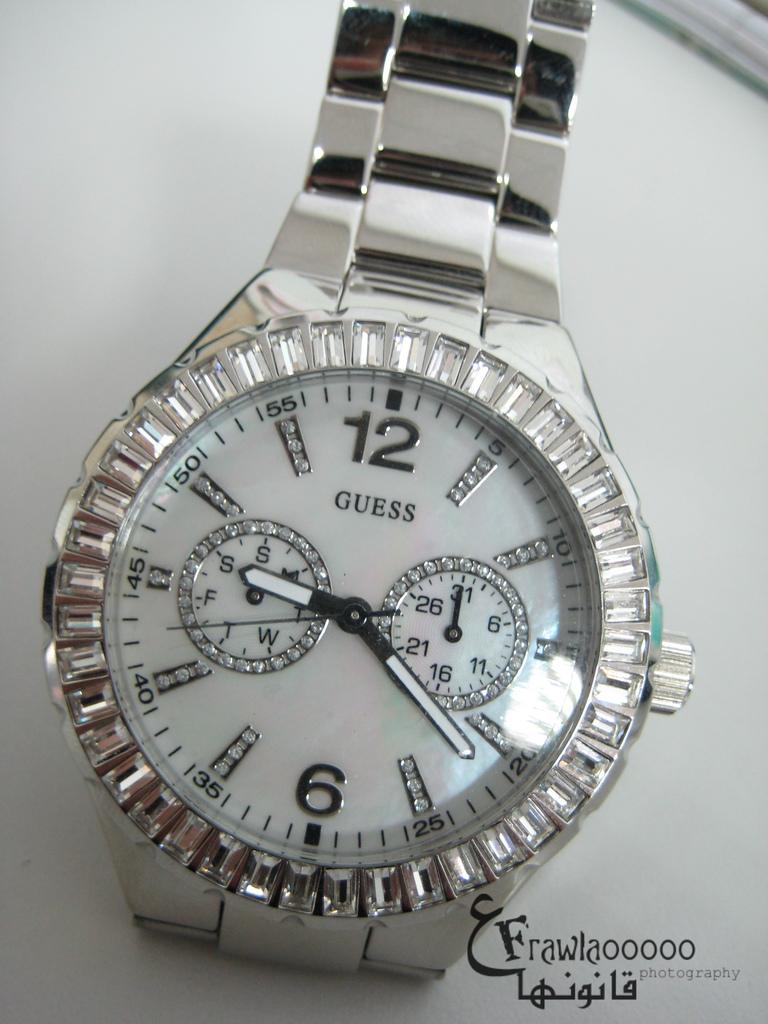Who made the time piece?
Offer a very short reply. Guess. 